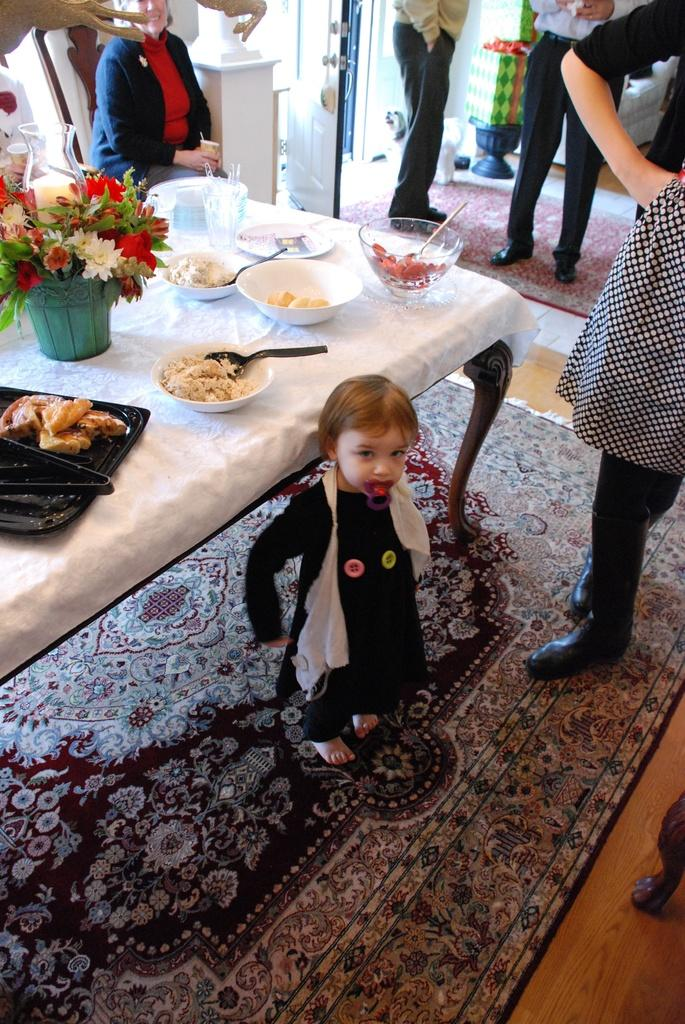What are the people in the image doing? The people in the image are standing. What is the woman doing in the image? The woman is sitting on a chair. What is on the table in the image? There is food, a flower pot, a bowl, a plate, and spoons on the table. What type of brush is being used to increase the size of the bowl in the image? There is no brush or attempt to increase the size of the bowl in the image. 